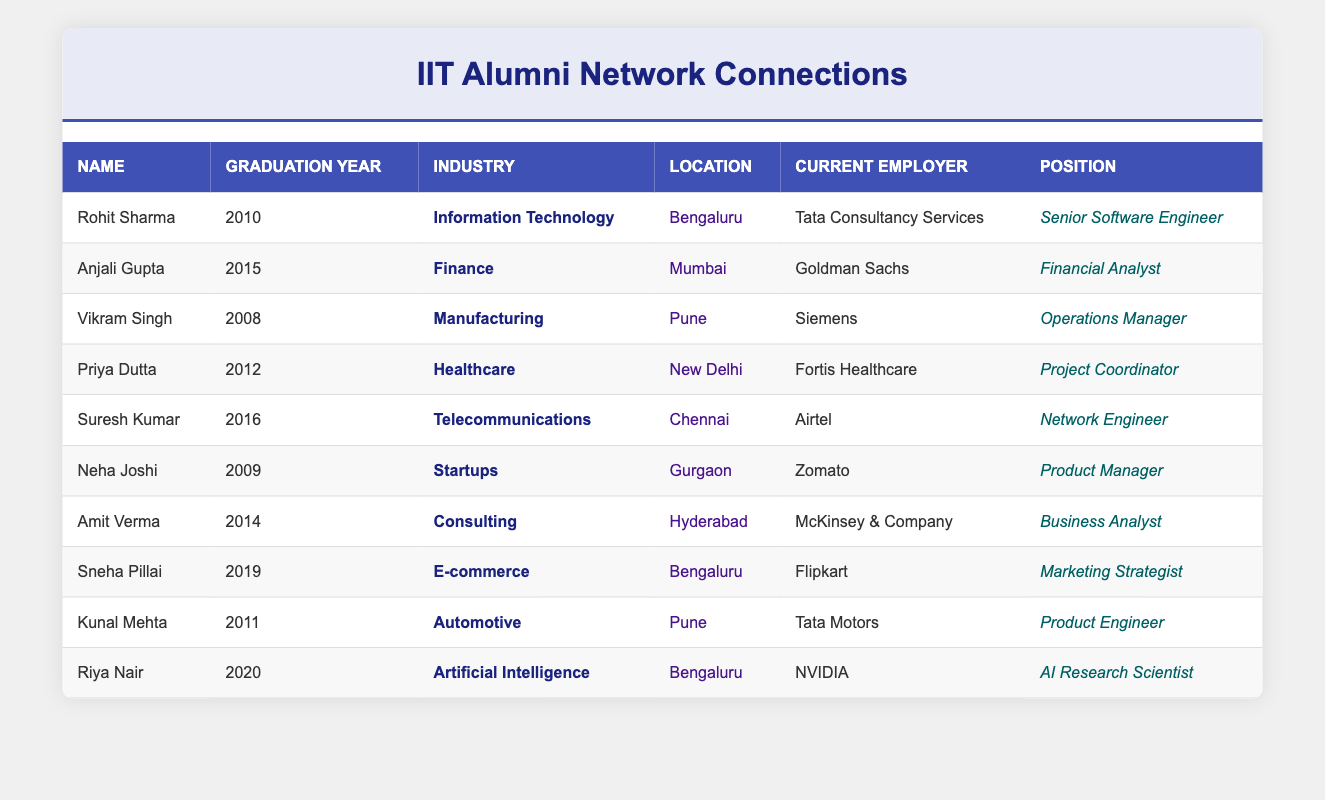What is the current employer of Rohit Sharma? Rohit Sharma is listed in the table with the current employer as Tata Consultancy Services. This information is directly available in the "Current Employer" column corresponding to Rohit Sharma's row.
Answer: Tata Consultancy Services How many alumni graduated in the year 2016? To answer this, I look through the "Graduation Year" column for the value 2016. Scanning the table, I find that there is one alumnus listed with this graduation year, which is Suresh Kumar.
Answer: 1 Which industry does Anjali Gupta work in? The table indicates that Anjali Gupta is associated with the Finance industry, as found in the "Industry" column corresponding to her row.
Answer: Finance Are there any alumni working in the Healthcare industry? I check the "Industry" column for the value Healthcare. The table shows that Priya Dutta is working in Healthcare, confirming that at least one alumnus is in this industry.
Answer: Yes What is the average graduation year of the alumni listed? First, I list the graduation years: 2010, 2015, 2008, 2012, 2016, 2009, 2014, 2019, 2011, and 2020. The total is 2010 + 2015 + 2008 + 2012 + 2016 + 2009 + 2014 + 2019 + 2011 + 2020 = 2010. There are 10 alumni, so I divide the total by 10 to get the average: 2010 / 10 = 2010.
Answer: 2010 Which alumnus works as a Product Manager and in which location? I scan the table for the position "Product Manager." The only alumnus in this position is Neha Joshi, and she is located in Gurgaon. So, Neha Joshi is the Product Manager in Gurgaon.
Answer: Neha Joshi, Gurgaon 